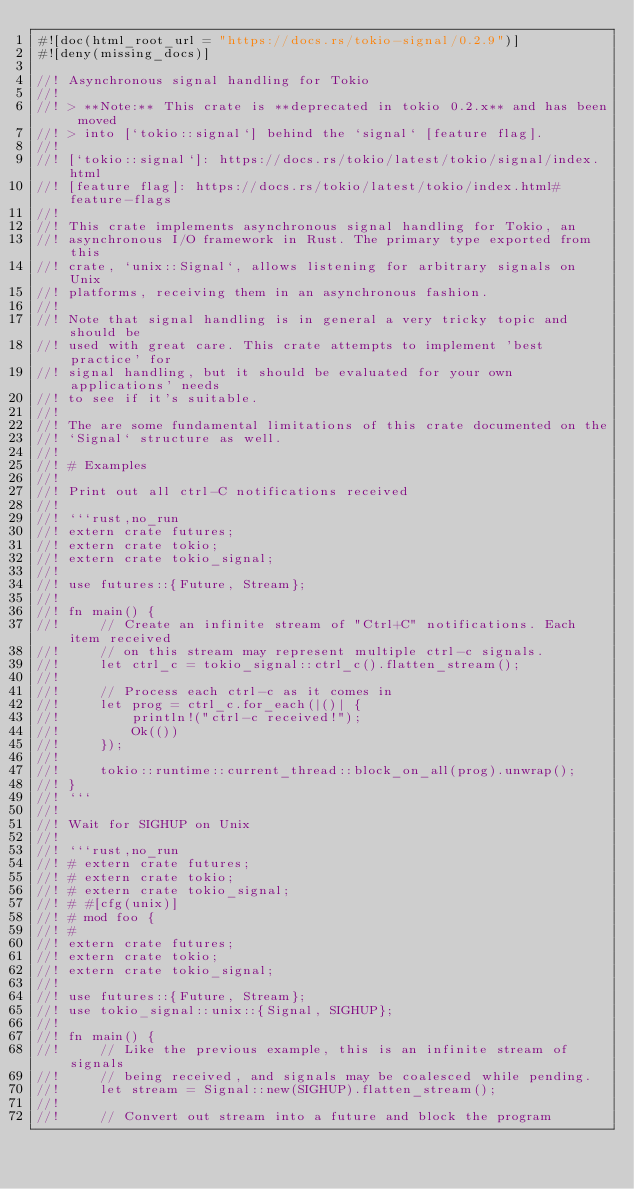<code> <loc_0><loc_0><loc_500><loc_500><_Rust_>#![doc(html_root_url = "https://docs.rs/tokio-signal/0.2.9")]
#![deny(missing_docs)]

//! Asynchronous signal handling for Tokio
//!
//! > **Note:** This crate is **deprecated in tokio 0.2.x** and has been moved
//! > into [`tokio::signal`] behind the `signal` [feature flag].
//!
//! [`tokio::signal`]: https://docs.rs/tokio/latest/tokio/signal/index.html
//! [feature flag]: https://docs.rs/tokio/latest/tokio/index.html#feature-flags
//!
//! This crate implements asynchronous signal handling for Tokio, an
//! asynchronous I/O framework in Rust. The primary type exported from this
//! crate, `unix::Signal`, allows listening for arbitrary signals on Unix
//! platforms, receiving them in an asynchronous fashion.
//!
//! Note that signal handling is in general a very tricky topic and should be
//! used with great care. This crate attempts to implement 'best practice' for
//! signal handling, but it should be evaluated for your own applications' needs
//! to see if it's suitable.
//!
//! The are some fundamental limitations of this crate documented on the
//! `Signal` structure as well.
//!
//! # Examples
//!
//! Print out all ctrl-C notifications received
//!
//! ```rust,no_run
//! extern crate futures;
//! extern crate tokio;
//! extern crate tokio_signal;
//!
//! use futures::{Future, Stream};
//!
//! fn main() {
//!     // Create an infinite stream of "Ctrl+C" notifications. Each item received
//!     // on this stream may represent multiple ctrl-c signals.
//!     let ctrl_c = tokio_signal::ctrl_c().flatten_stream();
//!
//!     // Process each ctrl-c as it comes in
//!     let prog = ctrl_c.for_each(|()| {
//!         println!("ctrl-c received!");
//!         Ok(())
//!     });
//!
//!     tokio::runtime::current_thread::block_on_all(prog).unwrap();
//! }
//! ```
//!
//! Wait for SIGHUP on Unix
//!
//! ```rust,no_run
//! # extern crate futures;
//! # extern crate tokio;
//! # extern crate tokio_signal;
//! # #[cfg(unix)]
//! # mod foo {
//! #
//! extern crate futures;
//! extern crate tokio;
//! extern crate tokio_signal;
//!
//! use futures::{Future, Stream};
//! use tokio_signal::unix::{Signal, SIGHUP};
//!
//! fn main() {
//!     // Like the previous example, this is an infinite stream of signals
//!     // being received, and signals may be coalesced while pending.
//!     let stream = Signal::new(SIGHUP).flatten_stream();
//!
//!     // Convert out stream into a future and block the program</code> 